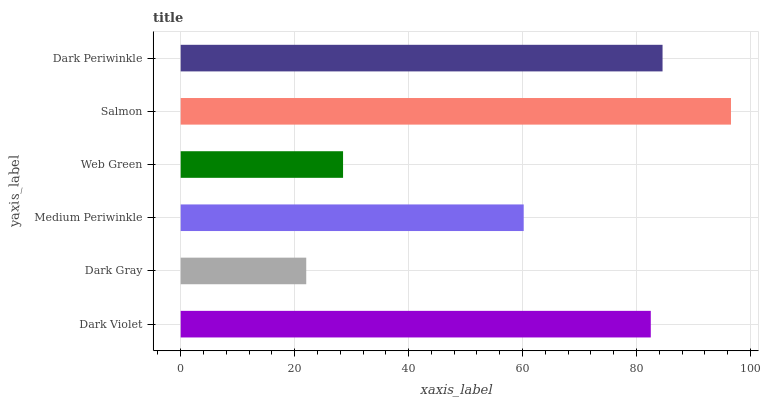Is Dark Gray the minimum?
Answer yes or no. Yes. Is Salmon the maximum?
Answer yes or no. Yes. Is Medium Periwinkle the minimum?
Answer yes or no. No. Is Medium Periwinkle the maximum?
Answer yes or no. No. Is Medium Periwinkle greater than Dark Gray?
Answer yes or no. Yes. Is Dark Gray less than Medium Periwinkle?
Answer yes or no. Yes. Is Dark Gray greater than Medium Periwinkle?
Answer yes or no. No. Is Medium Periwinkle less than Dark Gray?
Answer yes or no. No. Is Dark Violet the high median?
Answer yes or no. Yes. Is Medium Periwinkle the low median?
Answer yes or no. Yes. Is Salmon the high median?
Answer yes or no. No. Is Dark Violet the low median?
Answer yes or no. No. 